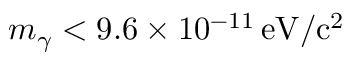Convert formula to latex. <formula><loc_0><loc_0><loc_500><loc_500>m _ { \gamma } < 9 . 6 \times 1 0 ^ { - 1 1 } \, e V / c ^ { 2 }</formula> 